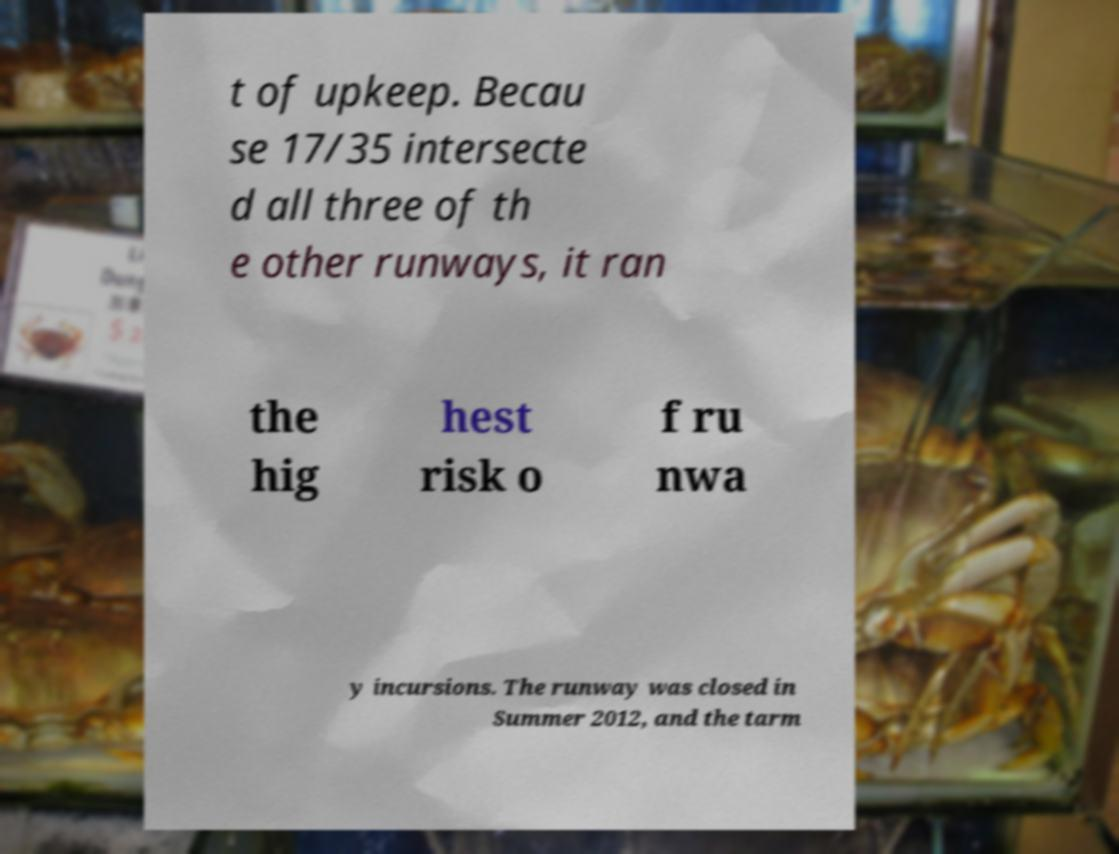What messages or text are displayed in this image? I need them in a readable, typed format. t of upkeep. Becau se 17/35 intersecte d all three of th e other runways, it ran the hig hest risk o f ru nwa y incursions. The runway was closed in Summer 2012, and the tarm 